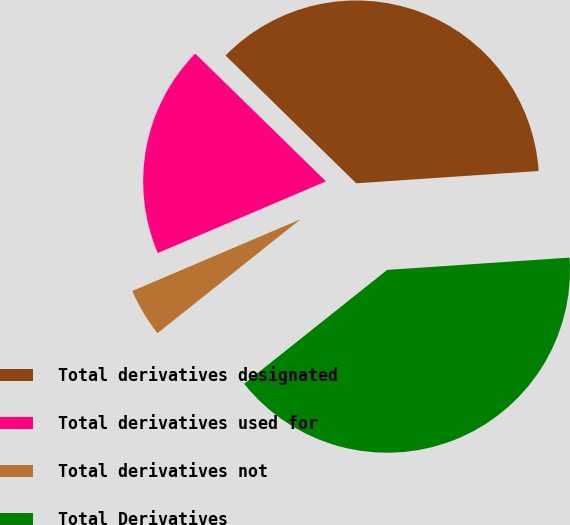<chart> <loc_0><loc_0><loc_500><loc_500><pie_chart><fcel>Total derivatives designated<fcel>Total derivatives used for<fcel>Total derivatives not<fcel>Total Derivatives<nl><fcel>36.61%<fcel>18.73%<fcel>4.29%<fcel>40.37%<nl></chart> 